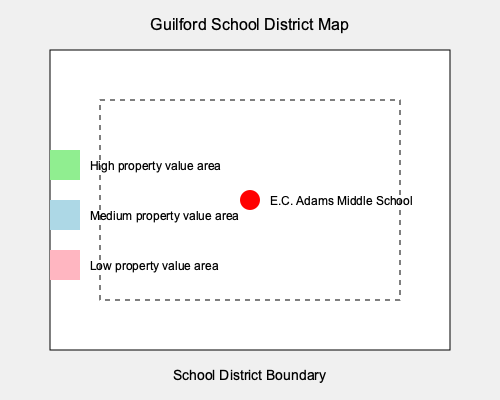Using the map of Guilford with E.C. Adams Middle School highlighted, analyze the potential impact of school district zoning on property values. Consider a scenario where the school district boundary is adjusted to exclude a previously included area. How would this change likely affect property values within a 1-mile radius of the school, and what economic principle explains this effect? Provide a quantitative estimate of the percentage change in property values. To analyze the impact of school district zoning on property values, we need to consider several factors:

1. Proximity effect: Properties closer to well-performing schools tend to have higher values.

2. Supply and demand: Exclusion of an area from the school district reduces the supply of homes with access to E.C. Adams Middle School, potentially increasing demand for remaining properties within the district.

3. Capitalization of school quality: The value of good schools is often "capitalized" into home prices.

4. Regression analysis: Studies have shown that homes within high-performing school districts can command a premium of 10-20% compared to similar homes in lower-performing districts.

To estimate the impact:

1. Assume E.C. Adams Middle School is well-performing.
2. Consider that excluding an area from the district boundary reduces supply.
3. Apply the principle of supply and demand: reduced supply with constant demand leads to increased prices.
4. Use the lower end of the typical premium range (10%) as a conservative estimate.
5. Factor in that the change is not district-wide but localized to a 1-mile radius.

Calculation:
- Base premium for good school district: 10%
- Localization factor (assuming half the effect due to specific area change): 0.5
- Estimated property value increase: $10\% \times 0.5 = 5\%$

The economic principle at work here is the capitalization of school quality into property values, combined with supply and demand dynamics in a geographically constrained market.
Answer: Approximately 5% increase in property values within a 1-mile radius of the school. 